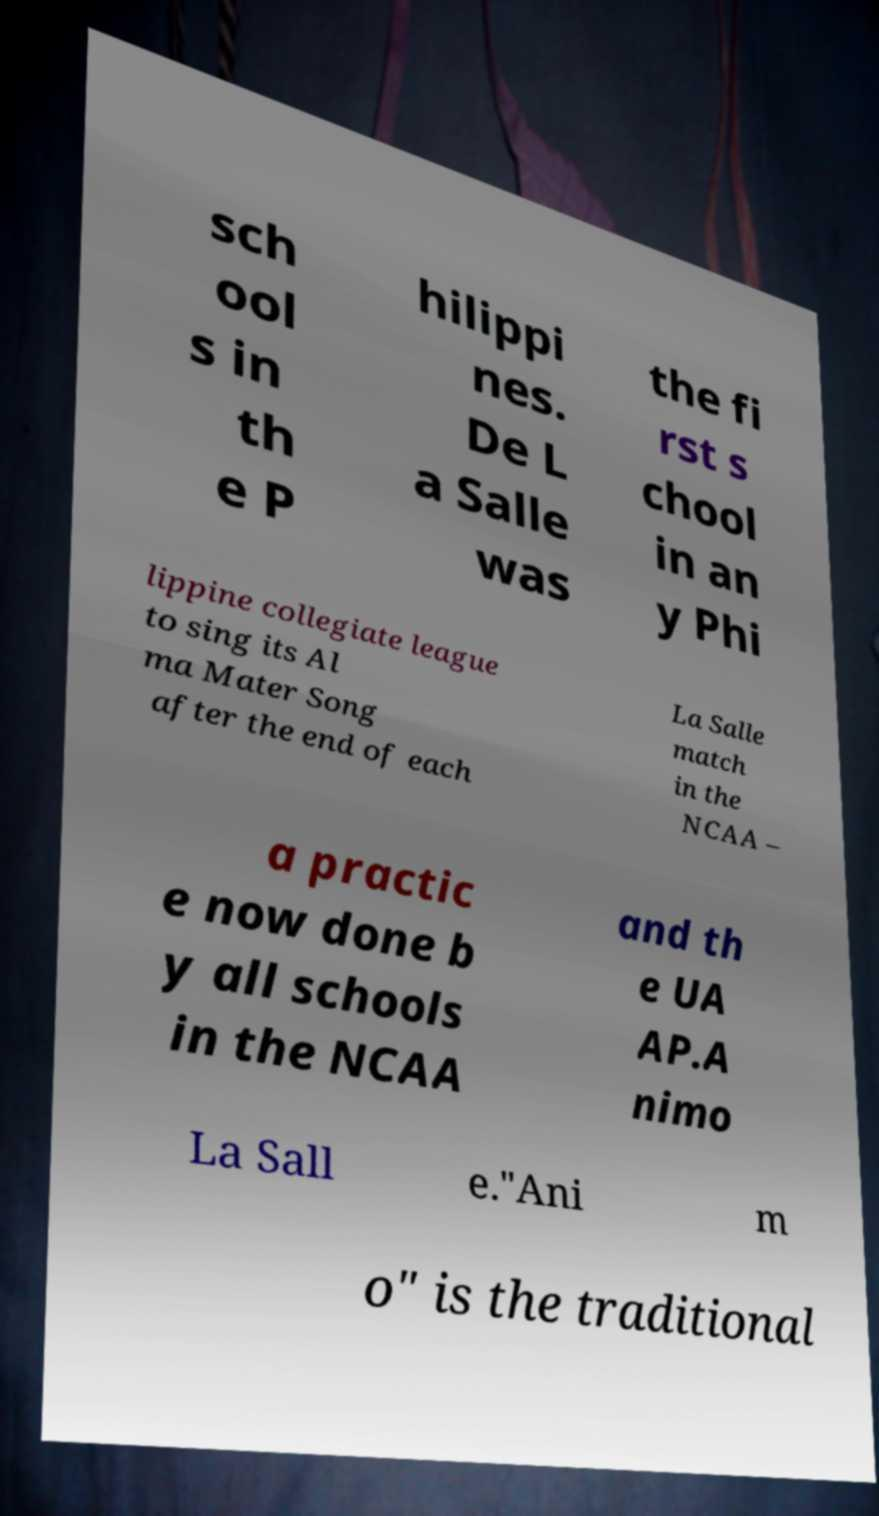Can you accurately transcribe the text from the provided image for me? sch ool s in th e P hilippi nes. De L a Salle was the fi rst s chool in an y Phi lippine collegiate league to sing its Al ma Mater Song after the end of each La Salle match in the NCAA – a practic e now done b y all schools in the NCAA and th e UA AP.A nimo La Sall e."Ani m o" is the traditional 